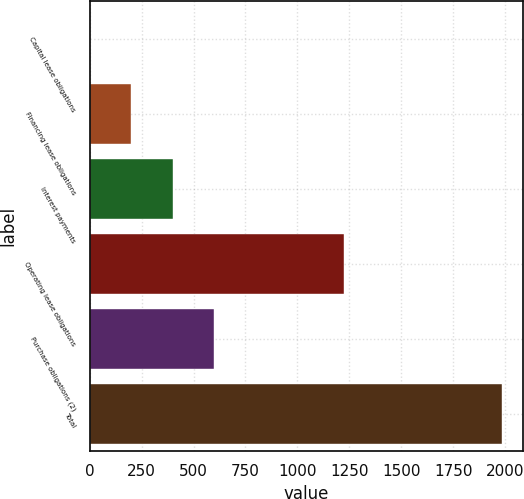<chart> <loc_0><loc_0><loc_500><loc_500><bar_chart><fcel>Capital lease obligations<fcel>Financing lease obligations<fcel>Interest payments<fcel>Operating lease obligations<fcel>Purchase obligations (2)<fcel>Total<nl><fcel>2<fcel>200.4<fcel>398.8<fcel>1224<fcel>597.2<fcel>1986<nl></chart> 